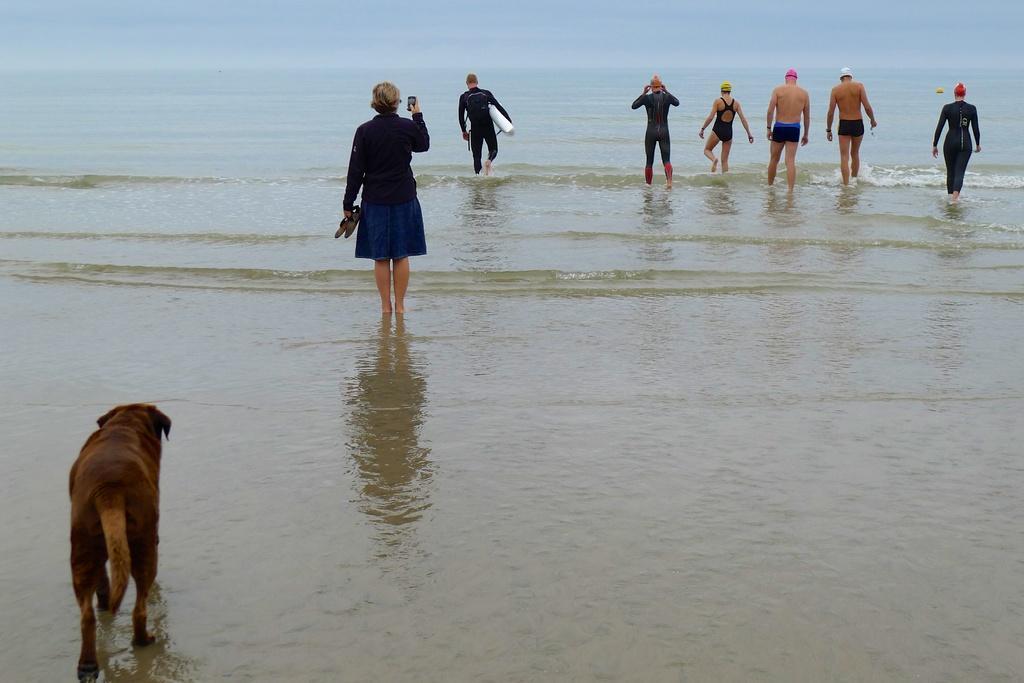How would you summarize this image in a sentence or two? In this image I can see few people are standing in the water. These people are wearing the different color dresses. I can see one person is holding the shoes and mobile. To the left I can see an animal which is in brown color. It is also in the water. 